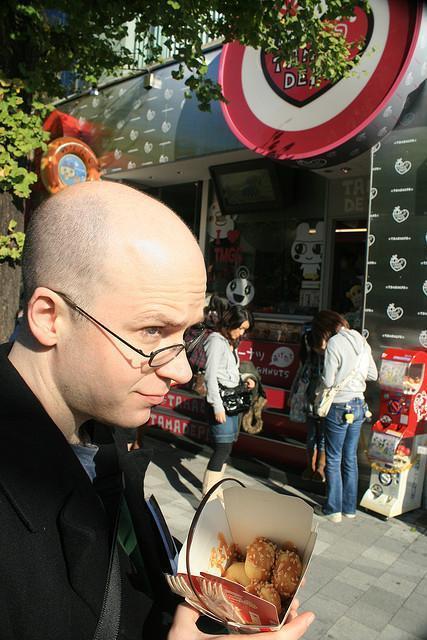How many people can you see?
Give a very brief answer. 4. How many chairs is in this setting?
Give a very brief answer. 0. 